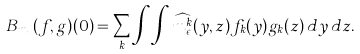Convert formula to latex. <formula><loc_0><loc_0><loc_500><loc_500>B _ { m _ { \epsilon } } ( f , g ) ( 0 ) = \sum _ { k } \int \int \widehat { m ^ { k } _ { \epsilon } } ( y , z ) f _ { k } ( y ) g _ { k } ( z ) \, d y \, d z .</formula> 